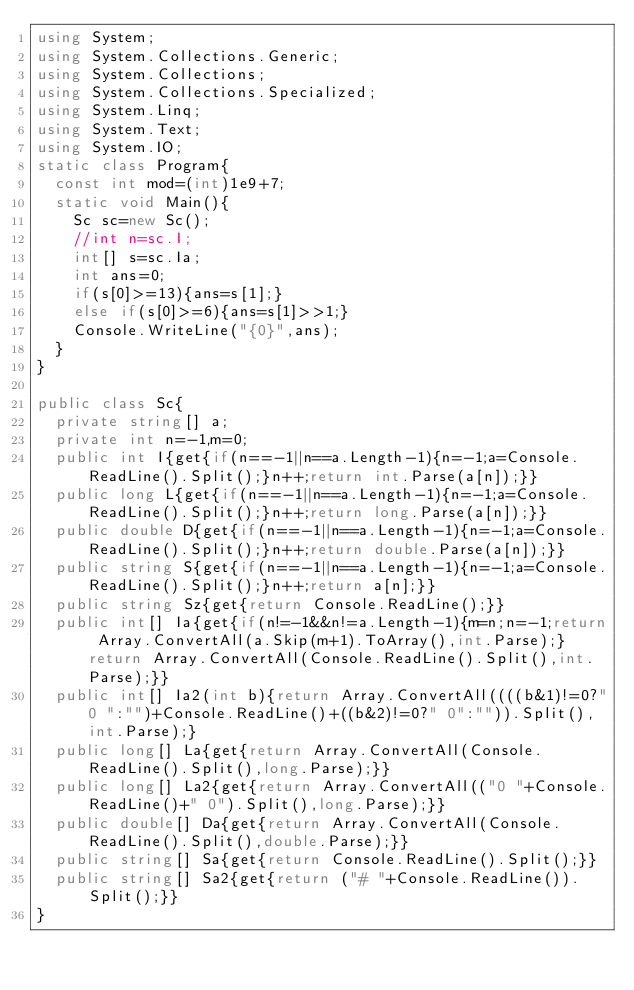Convert code to text. <code><loc_0><loc_0><loc_500><loc_500><_C#_>using System;
using System.Collections.Generic;
using System.Collections;
using System.Collections.Specialized;
using System.Linq;
using System.Text;
using System.IO;
static class Program{
	const int mod=(int)1e9+7;
	static void Main(){
		Sc sc=new Sc();
		//int n=sc.I;
		int[] s=sc.Ia;
		int ans=0;
		if(s[0]>=13){ans=s[1];}
		else if(s[0]>=6){ans=s[1]>>1;}
		Console.WriteLine("{0}",ans);
	}
}

public class Sc{
	private string[] a;
	private int n=-1,m=0;
	public int I{get{if(n==-1||n==a.Length-1){n=-1;a=Console.ReadLine().Split();}n++;return int.Parse(a[n]);}}
	public long L{get{if(n==-1||n==a.Length-1){n=-1;a=Console.ReadLine().Split();}n++;return long.Parse(a[n]);}}
	public double D{get{if(n==-1||n==a.Length-1){n=-1;a=Console.ReadLine().Split();}n++;return double.Parse(a[n]);}}
	public string S{get{if(n==-1||n==a.Length-1){n=-1;a=Console.ReadLine().Split();}n++;return a[n];}}
	public string Sz{get{return Console.ReadLine();}}
	public int[] Ia{get{if(n!=-1&&n!=a.Length-1){m=n;n=-1;return Array.ConvertAll(a.Skip(m+1).ToArray(),int.Parse);}return Array.ConvertAll(Console.ReadLine().Split(),int.Parse);}}
	public int[] Ia2(int b){return Array.ConvertAll((((b&1)!=0?"0 ":"")+Console.ReadLine()+((b&2)!=0?" 0":"")).Split(),int.Parse);}
	public long[] La{get{return Array.ConvertAll(Console.ReadLine().Split(),long.Parse);}}
	public long[] La2{get{return Array.ConvertAll(("0 "+Console.ReadLine()+" 0").Split(),long.Parse);}}
	public double[] Da{get{return Array.ConvertAll(Console.ReadLine().Split(),double.Parse);}}
	public string[] Sa{get{return Console.ReadLine().Split();}}
	public string[] Sa2{get{return ("# "+Console.ReadLine()).Split();}}
}
</code> 